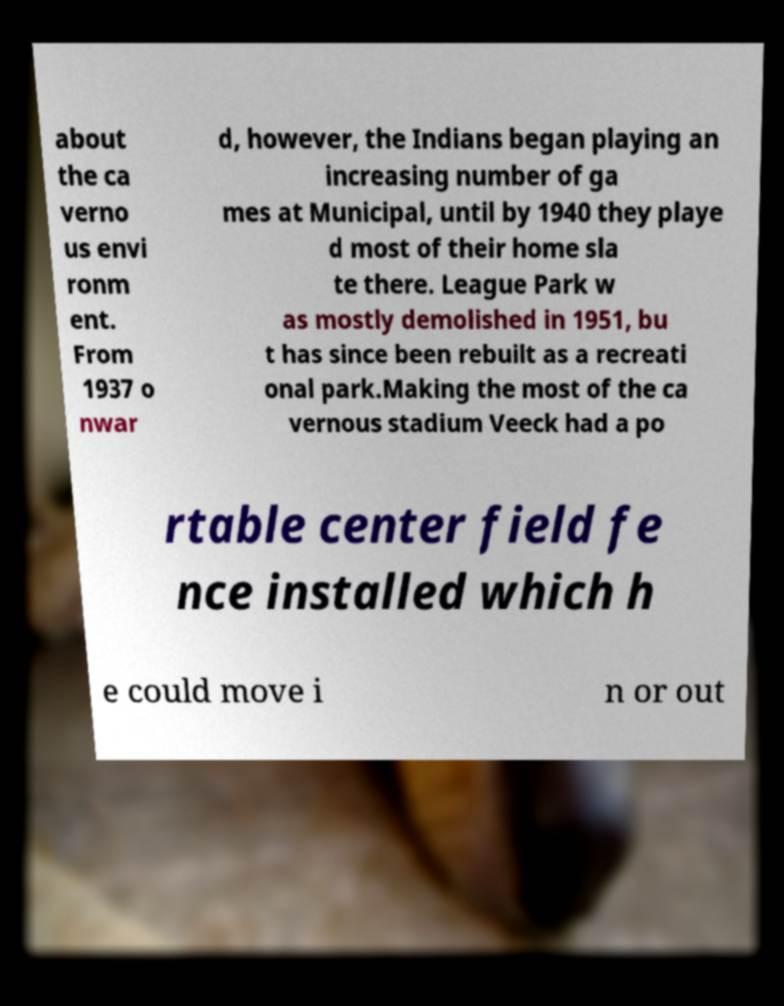There's text embedded in this image that I need extracted. Can you transcribe it verbatim? about the ca verno us envi ronm ent. From 1937 o nwar d, however, the Indians began playing an increasing number of ga mes at Municipal, until by 1940 they playe d most of their home sla te there. League Park w as mostly demolished in 1951, bu t has since been rebuilt as a recreati onal park.Making the most of the ca vernous stadium Veeck had a po rtable center field fe nce installed which h e could move i n or out 